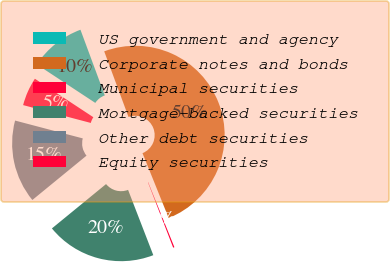<chart> <loc_0><loc_0><loc_500><loc_500><pie_chart><fcel>US government and agency<fcel>Corporate notes and bonds<fcel>Municipal securities<fcel>Mortgage-backed securities<fcel>Other debt securities<fcel>Equity securities<nl><fcel>10.09%<fcel>49.54%<fcel>0.23%<fcel>19.95%<fcel>15.02%<fcel>5.16%<nl></chart> 